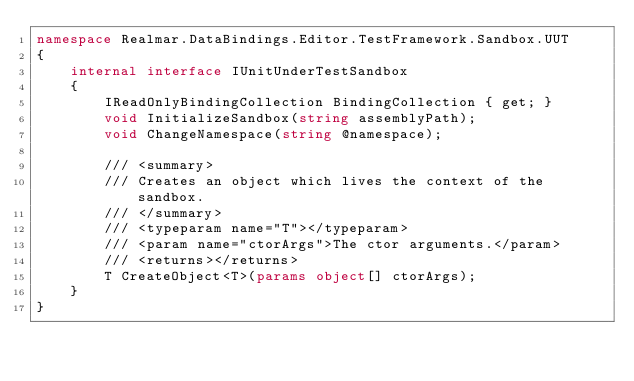<code> <loc_0><loc_0><loc_500><loc_500><_C#_>namespace Realmar.DataBindings.Editor.TestFramework.Sandbox.UUT
{
	internal interface IUnitUnderTestSandbox
	{
		IReadOnlyBindingCollection BindingCollection { get; }
		void InitializeSandbox(string assemblyPath);
		void ChangeNamespace(string @namespace);

		/// <summary>
		/// Creates an object which lives the context of the sandbox.
		/// </summary>
		/// <typeparam name="T"></typeparam>
		/// <param name="ctorArgs">The ctor arguments.</param>
		/// <returns></returns>
		T CreateObject<T>(params object[] ctorArgs);
	}
}
</code> 